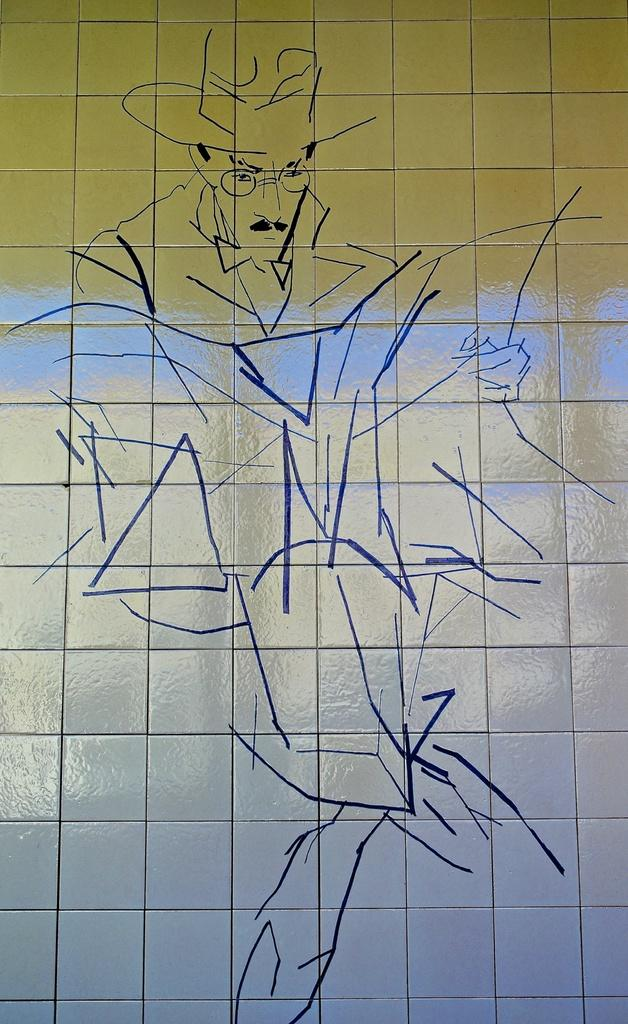What is the main subject of the wall sticker in the image? The wall sticker depicts a man sitting and reading a newspaper. Where is the wall sticker located in the image? The wall sticker is posted on a wall. How does the moon affect the man sitting and reading a newspaper in the image? The moon is not present in the image, so it cannot affect the man sitting and reading a newspaper. 